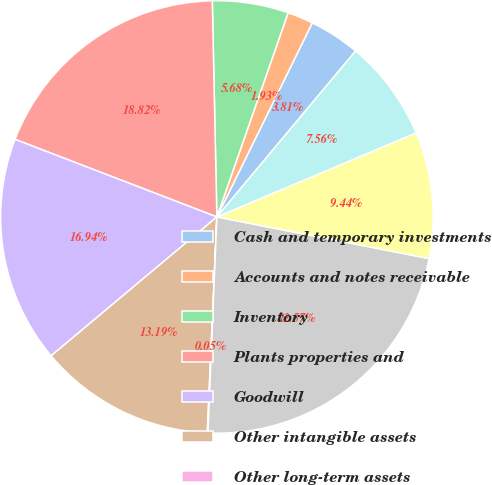Convert chart. <chart><loc_0><loc_0><loc_500><loc_500><pie_chart><fcel>Cash and temporary investments<fcel>Accounts and notes receivable<fcel>Inventory<fcel>Plants properties and<fcel>Goodwill<fcel>Other intangible assets<fcel>Other long-term assets<fcel>Total assets acquired<fcel>Accounts payable and accrued<fcel>Deferred income tax liability<nl><fcel>3.81%<fcel>1.93%<fcel>5.68%<fcel>18.82%<fcel>16.94%<fcel>13.19%<fcel>0.05%<fcel>22.57%<fcel>9.44%<fcel>7.56%<nl></chart> 